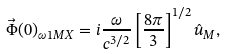Convert formula to latex. <formula><loc_0><loc_0><loc_500><loc_500>\vec { \Phi } ( 0 ) _ { \omega 1 M X } = i \frac { \omega } { c ^ { 3 / 2 } } \left [ \frac { 8 \pi } { 3 } \right ] ^ { 1 / 2 } \hat { u } _ { M } ,</formula> 